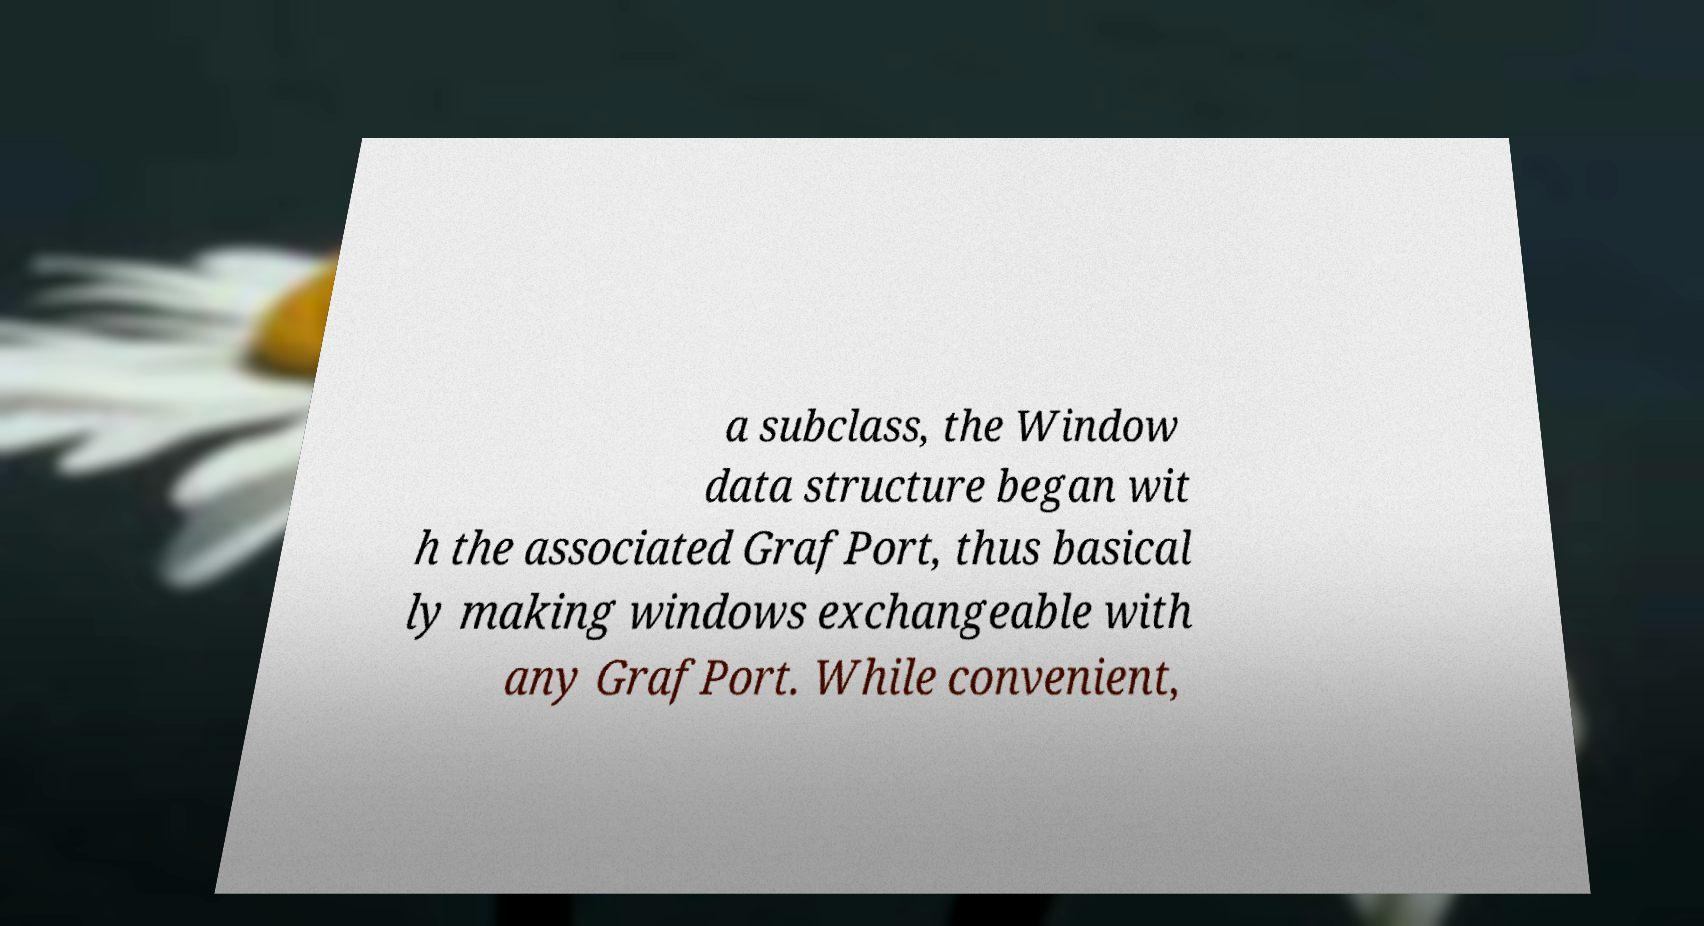For documentation purposes, I need the text within this image transcribed. Could you provide that? a subclass, the Window data structure began wit h the associated GrafPort, thus basical ly making windows exchangeable with any GrafPort. While convenient, 